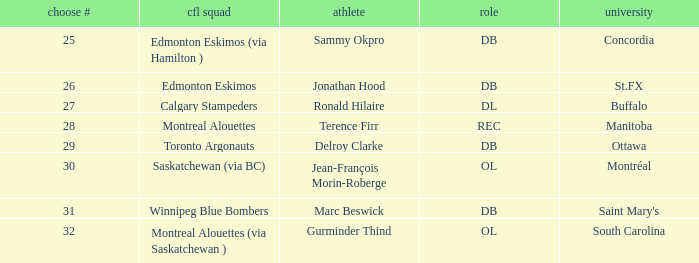What is buffalo's pick #? 27.0. 